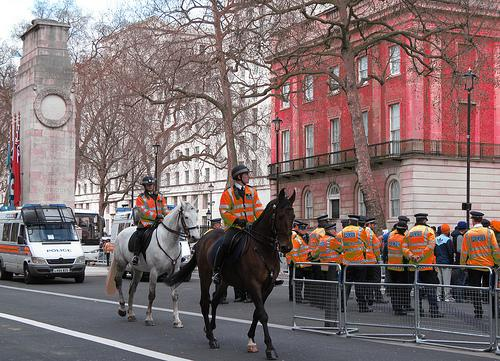What type of fence or barricade is present in the scene? A metal fence barricade, likely used for crowd control, is visible in the scene. What architectural detail stands out on the red building? The red building has five rectangular windows which make it visually appealing. Discuss the flags visible next to the van. There are several flags next to the police van, positioned against a tower, likely symbolizing the authority or presence of the law enforcement. Identify the types of horses being ridden by officers in the scene. The officers are riding two types of horses: one brown horse and one white horse. What color is the police van and what is distinctive about it? The police van is white with an orange stripe which makes it easily identifiable. Describe the police officers who are not on horseback. The police officers not riding horses can be seen standing around in a group, wearing orange vests. What is significant about the trees in the image, and what season could it be? The trees have no leaves on them, suggesting that it could be wintertime. Describe the overall scene and setting of the image. Several police officers, some on horses and others standing, are gathered in a city setting with a metal barricade, a red building, and trees without leaves visible, along with a police van and buildings in the background. Provide a general description of the tower in the image. The tower is a stone structure with a round circle detail, appearing to be a clock tower without a clock. What is the relationship between the two men on horses in the scene? The two men on horses are both police officers, working together as a part of the mounted patrol in the city. Find a small dog wearing a red collar that appears to be waiting next to the policemen. Its fur looks fluffy. There is no mention of a dog or any animal other than horses in the image, so this instruction will confuse the reader by describing a non-existent object. In the lower right corner of the image, you can see a partially hidden car behind the trees. What color is it? No, it's not mentioned in the image. Please focus on the unusual rainbow that emerges over the clock tower. Why do you think it appears that way? Firstly, there is no mention of any rainbow in the image. Secondly, the clock tower itself is said to be not having a clock; hence, it further misleads the reader into looking for two non-existent things. A mother and a child seem to be passing by the metal fence barricade. Can you tell if the child is holding the mother's hand? There is no mention of any mother and child in the image, and this instruction would lead the reader to search for specific interactions among non-existent human subjects. Could you describe the green umbrella near the metal barricade? It seems to be partially open. There is no mention of a green umbrella in the provided information, and this instruction would lead the reader to search for an object that is not present in the image. Notice the statue of a person holding a torch on top of the red building. Who does it represent? There is no mention of any statue on the red building for the reader to identify; hence, they would be misled by the instruction. 